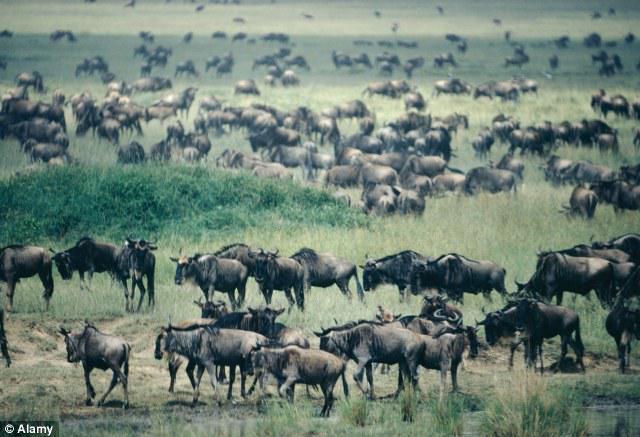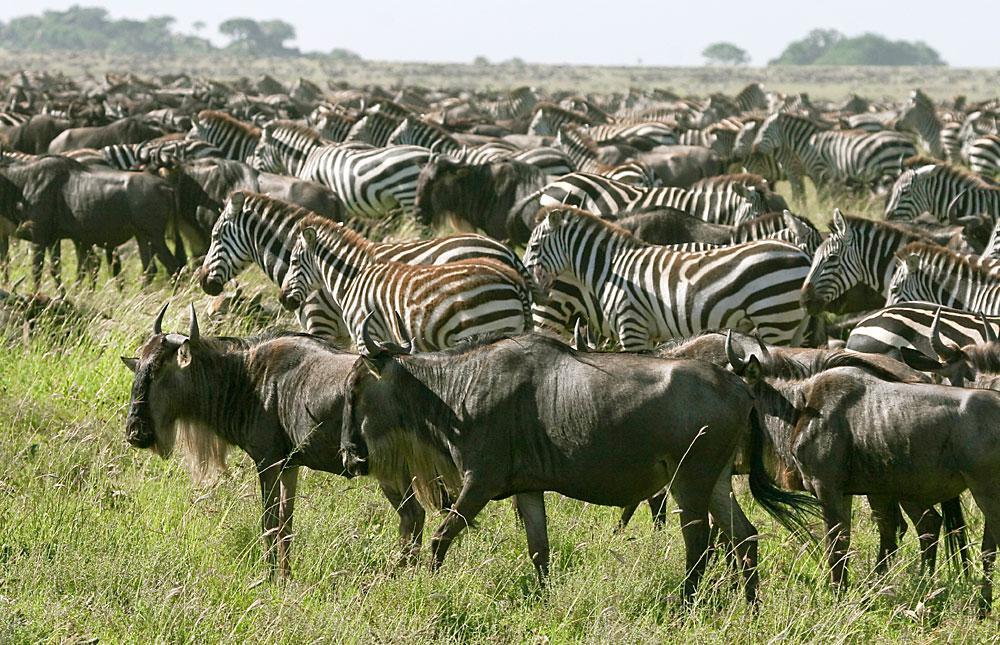The first image is the image on the left, the second image is the image on the right. Assess this claim about the two images: "In one image, only zebras and no other species can be seen.". Correct or not? Answer yes or no. No. The first image is the image on the left, the second image is the image on the right. For the images shown, is this caption "Multiple zebras and gnus, including multiple rear-facing animals, are at a watering hole in one image." true? Answer yes or no. No. 